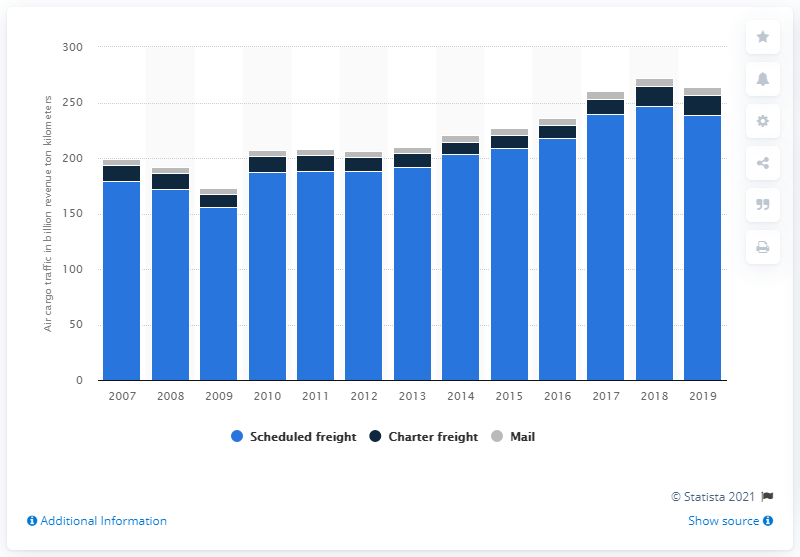Highlight a few significant elements in this photo. In 2019, the total revenue ton kilometers of charter freight traffic was 17.93. The previous year's charter freight traffic was 18.12... 